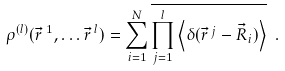<formula> <loc_0><loc_0><loc_500><loc_500>\rho ^ { ( l ) } ( \vec { r } \, ^ { 1 } , \dots \vec { r } \, ^ { l } ) = \sum _ { i = 1 } ^ { N } \overline { \prod _ { j = 1 } ^ { l } \left \langle \delta ( \vec { r } \, ^ { j } - \vec { R } _ { i } ) \right \rangle } \ .</formula> 